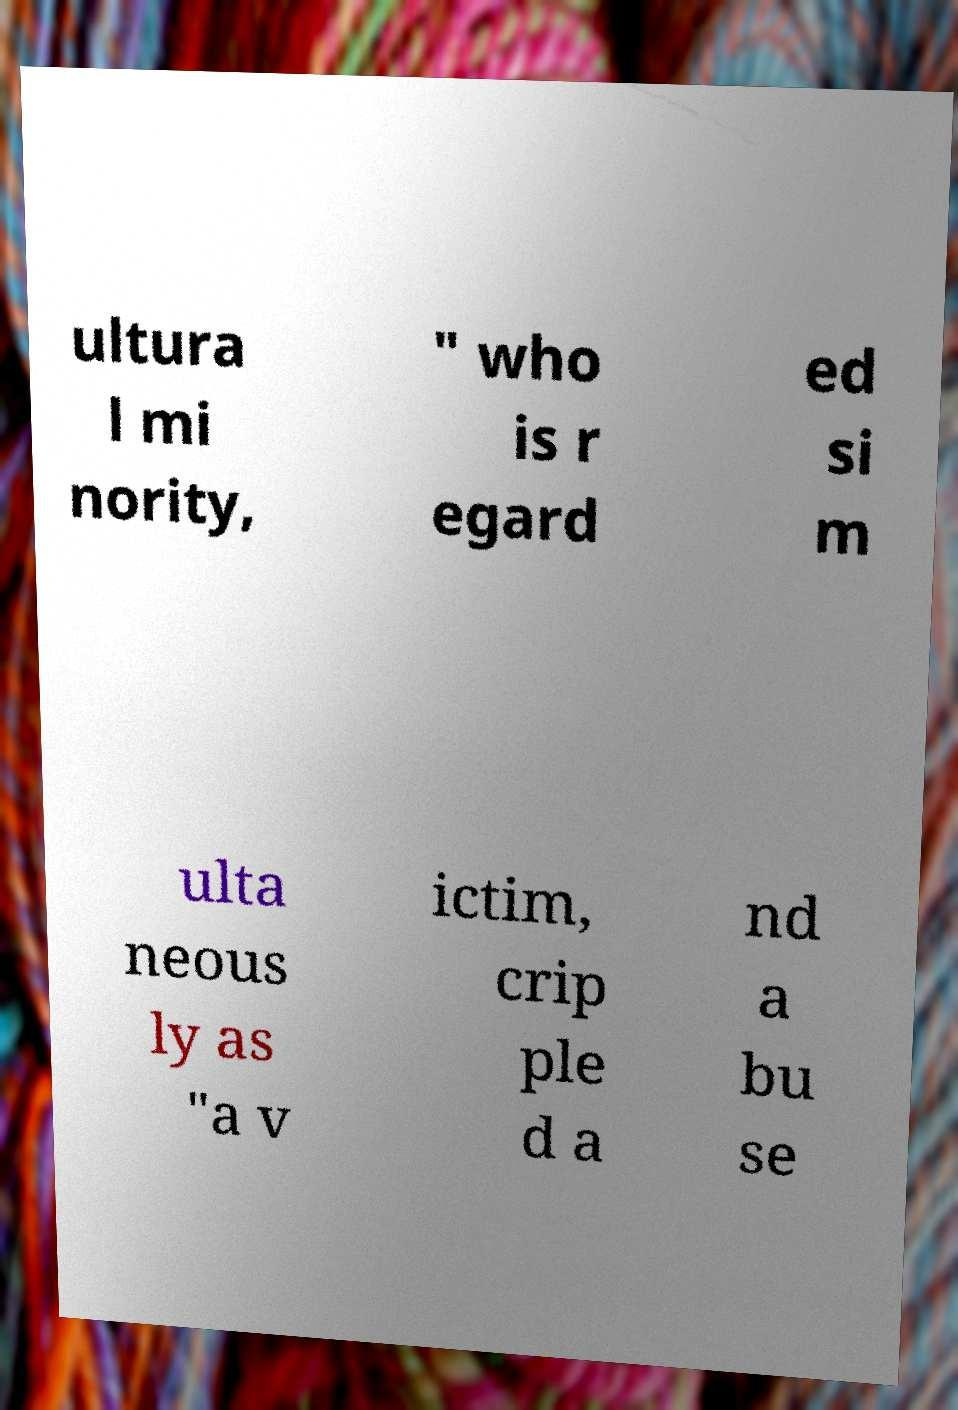There's text embedded in this image that I need extracted. Can you transcribe it verbatim? ultura l mi nority, " who is r egard ed si m ulta neous ly as "a v ictim, crip ple d a nd a bu se 